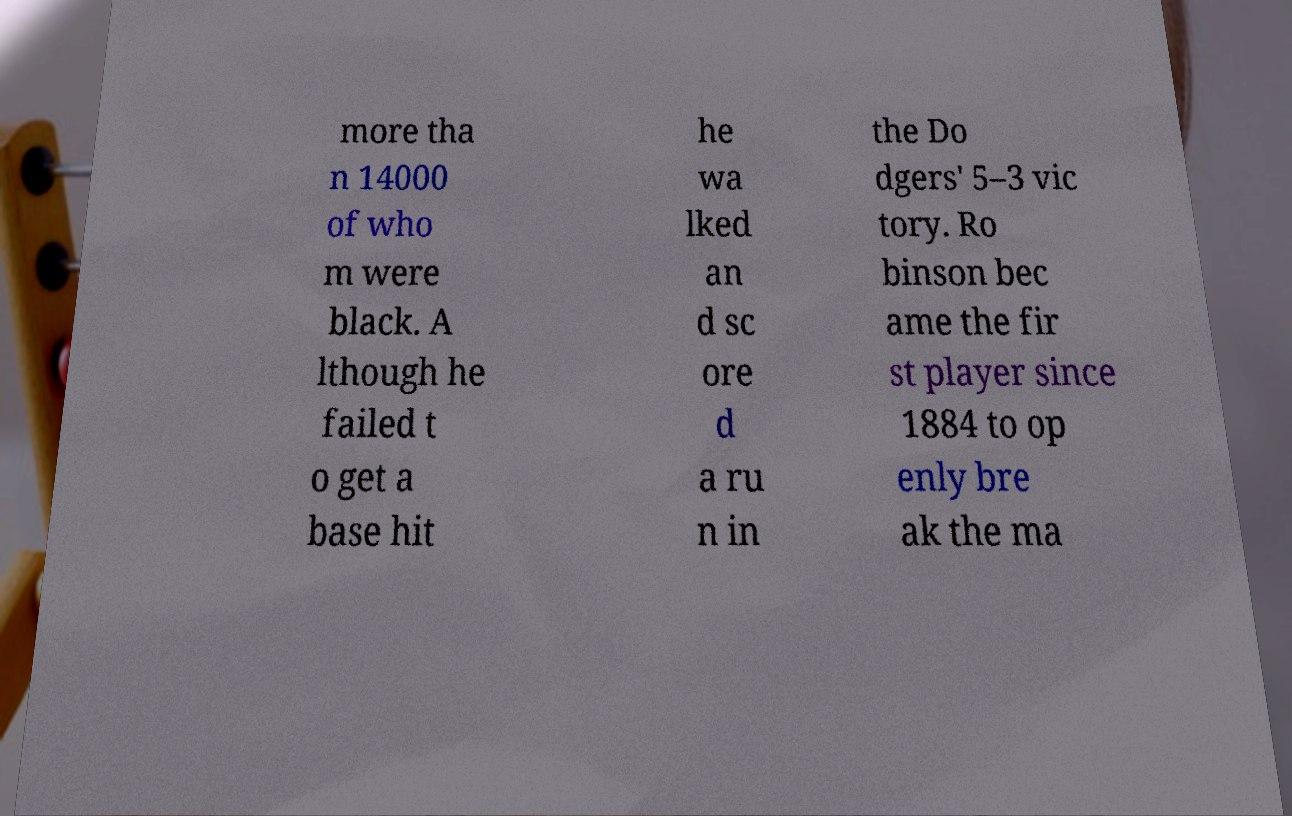For documentation purposes, I need the text within this image transcribed. Could you provide that? more tha n 14000 of who m were black. A lthough he failed t o get a base hit he wa lked an d sc ore d a ru n in the Do dgers' 5–3 vic tory. Ro binson bec ame the fir st player since 1884 to op enly bre ak the ma 